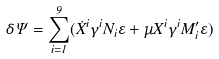Convert formula to latex. <formula><loc_0><loc_0><loc_500><loc_500>\delta \Psi = \sum _ { i = 1 } ^ { 9 } ( \dot { X } ^ { i } \gamma ^ { i } N _ { i } \varepsilon + \mu X ^ { i } \gamma ^ { i } M _ { i } ^ { \prime } \varepsilon )</formula> 